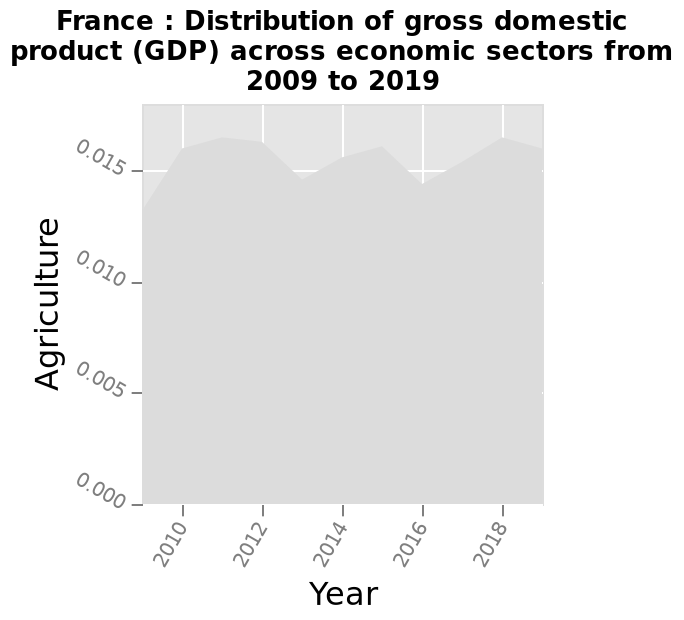<image>
Does the proportion of GDP from agriculture have a consistent upward or downward trend?  No, there appears to be no consistent upwards or downward trend in the proportion of GDP from agriculture. Does the proportion of GDP from agriculture fluctuate from year to year?  Yes, the proportion of GDP from agriculture fluctuates from year to year. What does the y-axis measure? The y-axis measures Agriculture. 